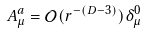Convert formula to latex. <formula><loc_0><loc_0><loc_500><loc_500>A ^ { a } _ { \mu } = \mathcal { O } ( r ^ { - ( D - 3 ) } ) \delta _ { \mu } ^ { 0 }</formula> 